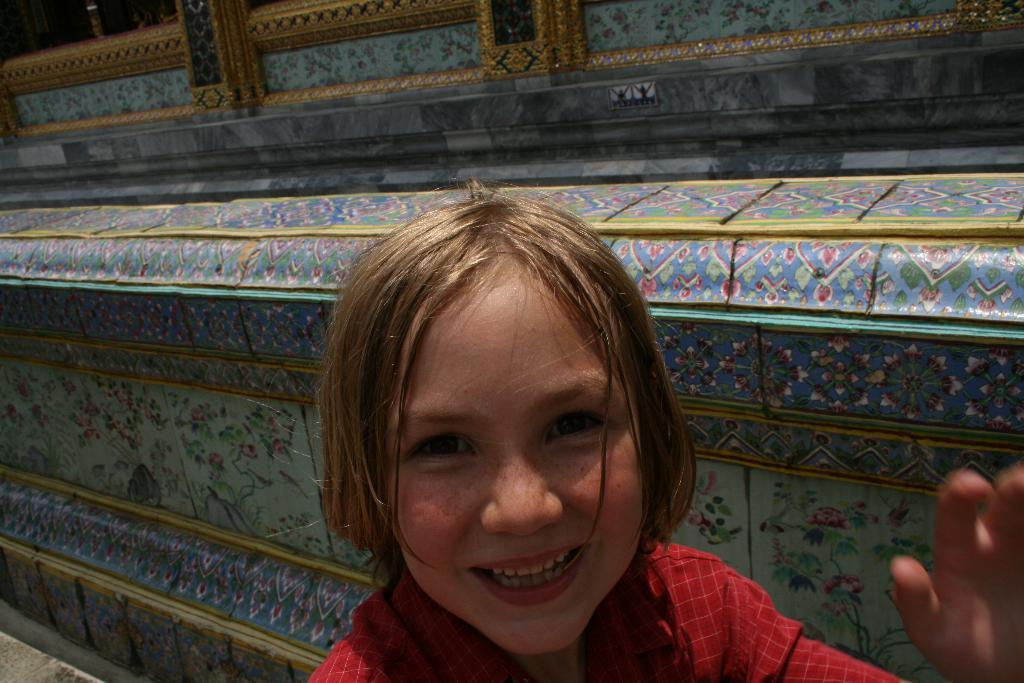Who is the main subject in the image? There is a child in the image. What is the child wearing? The child is wearing a red dress. What can be seen in the background of the image? There is a colorful building and a window visible in the background. What type of riddle can be solved by looking at the child's wing in the image? There is no wing present in the image, and therefore no riddle can be solved by looking at it. 